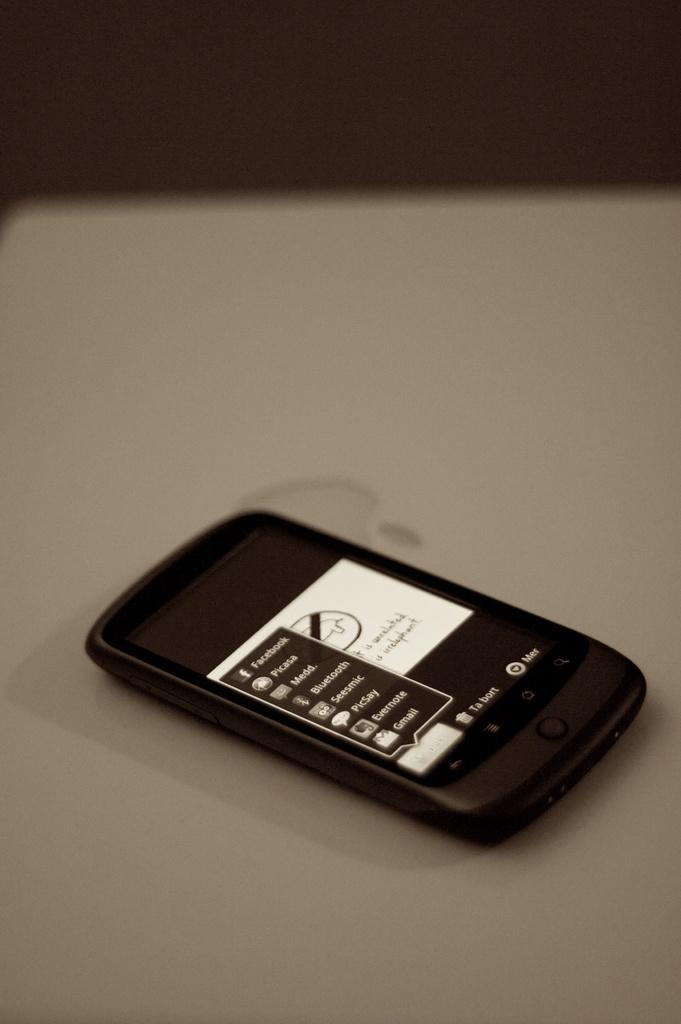What electronic device can be seen in the background of the image? There is a laptop in the background of the image. What is placed on the laptop? There is a mobile on the laptop. How many beds are visible in the image? There are no beds visible in the image. Are there any bikes present in the image? There is no mention of bikes in the provided facts, so it cannot be determined if any are present in the image. 